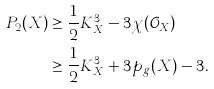<formula> <loc_0><loc_0><loc_500><loc_500>P _ { 2 } ( X ) & \geq \frac { 1 } { 2 } K _ { X } ^ { 3 } - 3 \chi ( { \mathcal { O } } _ { X } ) \\ & \geq \frac { 1 } { 2 } K _ { X } ^ { 3 } + 3 p _ { g } ( X ) - 3 .</formula> 